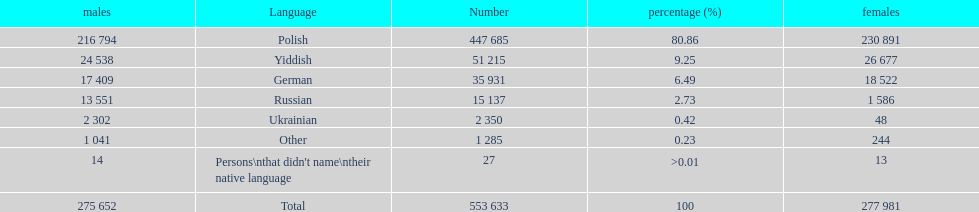How many languages have a name that is derived from a country? 4. 